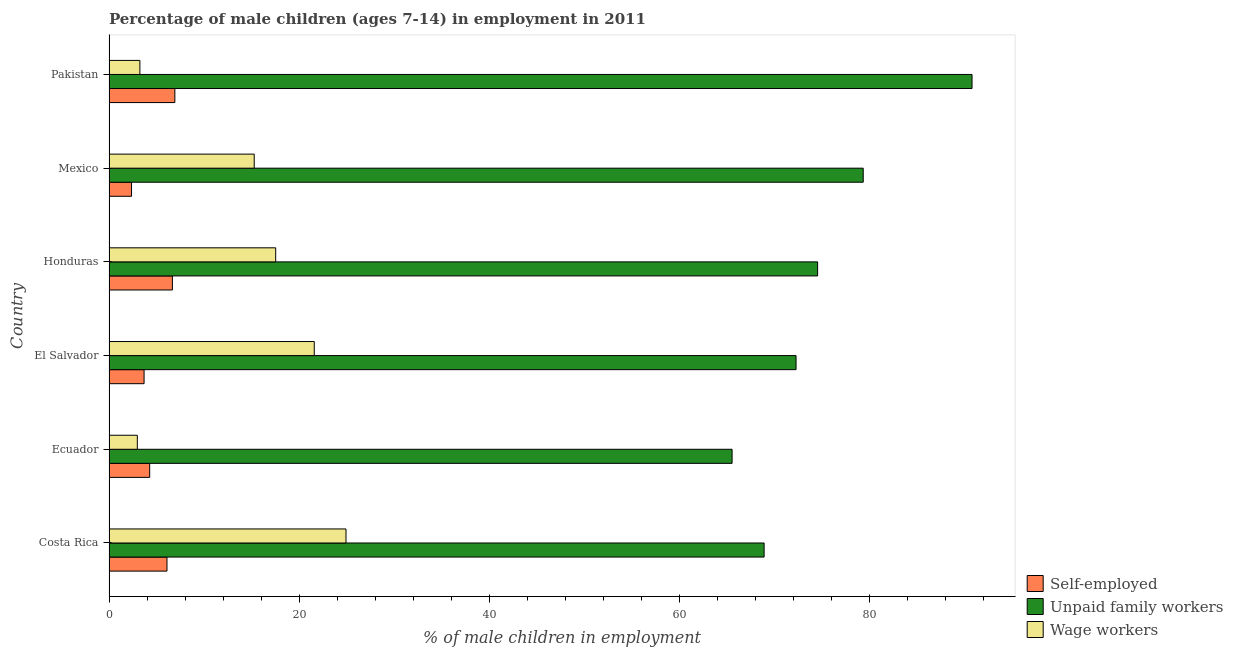How many different coloured bars are there?
Ensure brevity in your answer.  3. How many groups of bars are there?
Offer a terse response. 6. How many bars are there on the 5th tick from the bottom?
Your answer should be compact. 3. What is the percentage of children employed as wage workers in Ecuador?
Provide a succinct answer. 2.98. Across all countries, what is the maximum percentage of self employed children?
Give a very brief answer. 6.93. Across all countries, what is the minimum percentage of children employed as wage workers?
Give a very brief answer. 2.98. In which country was the percentage of children employed as wage workers maximum?
Keep it short and to the point. Costa Rica. What is the total percentage of self employed children in the graph?
Provide a short and direct response. 30.04. What is the difference between the percentage of children employed as wage workers in Mexico and that in Pakistan?
Provide a succinct answer. 12.03. What is the difference between the percentage of children employed as unpaid family workers in Costa Rica and the percentage of children employed as wage workers in Pakistan?
Offer a very short reply. 65.69. What is the average percentage of children employed as unpaid family workers per country?
Offer a terse response. 75.26. What is the difference between the percentage of children employed as wage workers and percentage of self employed children in Costa Rica?
Make the answer very short. 18.84. In how many countries, is the percentage of children employed as unpaid family workers greater than 80 %?
Ensure brevity in your answer.  1. What is the ratio of the percentage of children employed as wage workers in Costa Rica to that in El Salvador?
Give a very brief answer. 1.16. What is the difference between the highest and the second highest percentage of children employed as wage workers?
Provide a short and direct response. 3.34. What is the difference between the highest and the lowest percentage of self employed children?
Offer a very short reply. 4.56. Is the sum of the percentage of self employed children in Costa Rica and Pakistan greater than the maximum percentage of children employed as wage workers across all countries?
Ensure brevity in your answer.  No. What does the 1st bar from the top in El Salvador represents?
Keep it short and to the point. Wage workers. What does the 1st bar from the bottom in Pakistan represents?
Your answer should be compact. Self-employed. Are all the bars in the graph horizontal?
Your answer should be compact. Yes. How many countries are there in the graph?
Offer a terse response. 6. Are the values on the major ticks of X-axis written in scientific E-notation?
Your answer should be compact. No. Does the graph contain any zero values?
Your answer should be compact. No. Where does the legend appear in the graph?
Give a very brief answer. Bottom right. How many legend labels are there?
Offer a terse response. 3. What is the title of the graph?
Provide a short and direct response. Percentage of male children (ages 7-14) in employment in 2011. Does "Social Insurance" appear as one of the legend labels in the graph?
Offer a very short reply. No. What is the label or title of the X-axis?
Your answer should be compact. % of male children in employment. What is the % of male children in employment in Self-employed in Costa Rica?
Offer a terse response. 6.1. What is the % of male children in employment in Unpaid family workers in Costa Rica?
Keep it short and to the point. 68.94. What is the % of male children in employment of Wage workers in Costa Rica?
Provide a short and direct response. 24.94. What is the % of male children in employment in Self-employed in Ecuador?
Ensure brevity in your answer.  4.28. What is the % of male children in employment in Unpaid family workers in Ecuador?
Offer a terse response. 65.57. What is the % of male children in employment in Wage workers in Ecuador?
Provide a short and direct response. 2.98. What is the % of male children in employment of Self-employed in El Salvador?
Provide a succinct answer. 3.69. What is the % of male children in employment of Unpaid family workers in El Salvador?
Ensure brevity in your answer.  72.3. What is the % of male children in employment of Wage workers in El Salvador?
Provide a succinct answer. 21.6. What is the % of male children in employment in Self-employed in Honduras?
Ensure brevity in your answer.  6.67. What is the % of male children in employment of Unpaid family workers in Honduras?
Provide a short and direct response. 74.57. What is the % of male children in employment of Wage workers in Honduras?
Make the answer very short. 17.54. What is the % of male children in employment of Self-employed in Mexico?
Offer a terse response. 2.37. What is the % of male children in employment of Unpaid family workers in Mexico?
Give a very brief answer. 79.37. What is the % of male children in employment in Wage workers in Mexico?
Ensure brevity in your answer.  15.28. What is the % of male children in employment in Self-employed in Pakistan?
Offer a terse response. 6.93. What is the % of male children in employment of Unpaid family workers in Pakistan?
Your answer should be very brief. 90.82. Across all countries, what is the maximum % of male children in employment in Self-employed?
Your answer should be very brief. 6.93. Across all countries, what is the maximum % of male children in employment in Unpaid family workers?
Give a very brief answer. 90.82. Across all countries, what is the maximum % of male children in employment of Wage workers?
Keep it short and to the point. 24.94. Across all countries, what is the minimum % of male children in employment of Self-employed?
Provide a short and direct response. 2.37. Across all countries, what is the minimum % of male children in employment of Unpaid family workers?
Ensure brevity in your answer.  65.57. Across all countries, what is the minimum % of male children in employment of Wage workers?
Ensure brevity in your answer.  2.98. What is the total % of male children in employment of Self-employed in the graph?
Offer a very short reply. 30.04. What is the total % of male children in employment in Unpaid family workers in the graph?
Ensure brevity in your answer.  451.57. What is the total % of male children in employment in Wage workers in the graph?
Offer a very short reply. 85.59. What is the difference between the % of male children in employment in Self-employed in Costa Rica and that in Ecuador?
Your answer should be compact. 1.82. What is the difference between the % of male children in employment in Unpaid family workers in Costa Rica and that in Ecuador?
Give a very brief answer. 3.37. What is the difference between the % of male children in employment of Wage workers in Costa Rica and that in Ecuador?
Ensure brevity in your answer.  21.96. What is the difference between the % of male children in employment in Self-employed in Costa Rica and that in El Salvador?
Ensure brevity in your answer.  2.41. What is the difference between the % of male children in employment of Unpaid family workers in Costa Rica and that in El Salvador?
Your answer should be compact. -3.36. What is the difference between the % of male children in employment of Wage workers in Costa Rica and that in El Salvador?
Offer a terse response. 3.34. What is the difference between the % of male children in employment of Self-employed in Costa Rica and that in Honduras?
Give a very brief answer. -0.57. What is the difference between the % of male children in employment of Unpaid family workers in Costa Rica and that in Honduras?
Offer a terse response. -5.63. What is the difference between the % of male children in employment of Self-employed in Costa Rica and that in Mexico?
Keep it short and to the point. 3.73. What is the difference between the % of male children in employment of Unpaid family workers in Costa Rica and that in Mexico?
Give a very brief answer. -10.43. What is the difference between the % of male children in employment of Wage workers in Costa Rica and that in Mexico?
Your response must be concise. 9.66. What is the difference between the % of male children in employment in Self-employed in Costa Rica and that in Pakistan?
Your answer should be compact. -0.83. What is the difference between the % of male children in employment of Unpaid family workers in Costa Rica and that in Pakistan?
Your response must be concise. -21.88. What is the difference between the % of male children in employment of Wage workers in Costa Rica and that in Pakistan?
Offer a terse response. 21.69. What is the difference between the % of male children in employment in Self-employed in Ecuador and that in El Salvador?
Your response must be concise. 0.59. What is the difference between the % of male children in employment of Unpaid family workers in Ecuador and that in El Salvador?
Provide a short and direct response. -6.73. What is the difference between the % of male children in employment of Wage workers in Ecuador and that in El Salvador?
Keep it short and to the point. -18.62. What is the difference between the % of male children in employment of Self-employed in Ecuador and that in Honduras?
Your answer should be very brief. -2.39. What is the difference between the % of male children in employment in Wage workers in Ecuador and that in Honduras?
Your answer should be very brief. -14.56. What is the difference between the % of male children in employment of Self-employed in Ecuador and that in Mexico?
Provide a short and direct response. 1.91. What is the difference between the % of male children in employment in Unpaid family workers in Ecuador and that in Mexico?
Your response must be concise. -13.8. What is the difference between the % of male children in employment of Self-employed in Ecuador and that in Pakistan?
Your answer should be very brief. -2.65. What is the difference between the % of male children in employment of Unpaid family workers in Ecuador and that in Pakistan?
Offer a very short reply. -25.25. What is the difference between the % of male children in employment in Wage workers in Ecuador and that in Pakistan?
Make the answer very short. -0.27. What is the difference between the % of male children in employment in Self-employed in El Salvador and that in Honduras?
Your answer should be very brief. -2.98. What is the difference between the % of male children in employment of Unpaid family workers in El Salvador and that in Honduras?
Your answer should be compact. -2.27. What is the difference between the % of male children in employment in Wage workers in El Salvador and that in Honduras?
Provide a short and direct response. 4.06. What is the difference between the % of male children in employment of Self-employed in El Salvador and that in Mexico?
Your answer should be compact. 1.32. What is the difference between the % of male children in employment of Unpaid family workers in El Salvador and that in Mexico?
Give a very brief answer. -7.07. What is the difference between the % of male children in employment of Wage workers in El Salvador and that in Mexico?
Provide a short and direct response. 6.32. What is the difference between the % of male children in employment of Self-employed in El Salvador and that in Pakistan?
Make the answer very short. -3.24. What is the difference between the % of male children in employment of Unpaid family workers in El Salvador and that in Pakistan?
Your answer should be compact. -18.52. What is the difference between the % of male children in employment of Wage workers in El Salvador and that in Pakistan?
Ensure brevity in your answer.  18.35. What is the difference between the % of male children in employment in Unpaid family workers in Honduras and that in Mexico?
Give a very brief answer. -4.8. What is the difference between the % of male children in employment of Wage workers in Honduras and that in Mexico?
Offer a very short reply. 2.26. What is the difference between the % of male children in employment of Self-employed in Honduras and that in Pakistan?
Your answer should be very brief. -0.26. What is the difference between the % of male children in employment in Unpaid family workers in Honduras and that in Pakistan?
Offer a very short reply. -16.25. What is the difference between the % of male children in employment of Wage workers in Honduras and that in Pakistan?
Your answer should be compact. 14.29. What is the difference between the % of male children in employment in Self-employed in Mexico and that in Pakistan?
Offer a terse response. -4.56. What is the difference between the % of male children in employment in Unpaid family workers in Mexico and that in Pakistan?
Your response must be concise. -11.45. What is the difference between the % of male children in employment of Wage workers in Mexico and that in Pakistan?
Offer a terse response. 12.03. What is the difference between the % of male children in employment in Self-employed in Costa Rica and the % of male children in employment in Unpaid family workers in Ecuador?
Keep it short and to the point. -59.47. What is the difference between the % of male children in employment in Self-employed in Costa Rica and the % of male children in employment in Wage workers in Ecuador?
Provide a short and direct response. 3.12. What is the difference between the % of male children in employment of Unpaid family workers in Costa Rica and the % of male children in employment of Wage workers in Ecuador?
Your response must be concise. 65.96. What is the difference between the % of male children in employment in Self-employed in Costa Rica and the % of male children in employment in Unpaid family workers in El Salvador?
Provide a short and direct response. -66.2. What is the difference between the % of male children in employment in Self-employed in Costa Rica and the % of male children in employment in Wage workers in El Salvador?
Provide a short and direct response. -15.5. What is the difference between the % of male children in employment of Unpaid family workers in Costa Rica and the % of male children in employment of Wage workers in El Salvador?
Give a very brief answer. 47.34. What is the difference between the % of male children in employment of Self-employed in Costa Rica and the % of male children in employment of Unpaid family workers in Honduras?
Your response must be concise. -68.47. What is the difference between the % of male children in employment in Self-employed in Costa Rica and the % of male children in employment in Wage workers in Honduras?
Give a very brief answer. -11.44. What is the difference between the % of male children in employment in Unpaid family workers in Costa Rica and the % of male children in employment in Wage workers in Honduras?
Give a very brief answer. 51.4. What is the difference between the % of male children in employment in Self-employed in Costa Rica and the % of male children in employment in Unpaid family workers in Mexico?
Make the answer very short. -73.27. What is the difference between the % of male children in employment in Self-employed in Costa Rica and the % of male children in employment in Wage workers in Mexico?
Your response must be concise. -9.18. What is the difference between the % of male children in employment of Unpaid family workers in Costa Rica and the % of male children in employment of Wage workers in Mexico?
Ensure brevity in your answer.  53.66. What is the difference between the % of male children in employment in Self-employed in Costa Rica and the % of male children in employment in Unpaid family workers in Pakistan?
Offer a very short reply. -84.72. What is the difference between the % of male children in employment of Self-employed in Costa Rica and the % of male children in employment of Wage workers in Pakistan?
Make the answer very short. 2.85. What is the difference between the % of male children in employment of Unpaid family workers in Costa Rica and the % of male children in employment of Wage workers in Pakistan?
Provide a short and direct response. 65.69. What is the difference between the % of male children in employment of Self-employed in Ecuador and the % of male children in employment of Unpaid family workers in El Salvador?
Make the answer very short. -68.02. What is the difference between the % of male children in employment in Self-employed in Ecuador and the % of male children in employment in Wage workers in El Salvador?
Offer a very short reply. -17.32. What is the difference between the % of male children in employment of Unpaid family workers in Ecuador and the % of male children in employment of Wage workers in El Salvador?
Offer a terse response. 43.97. What is the difference between the % of male children in employment of Self-employed in Ecuador and the % of male children in employment of Unpaid family workers in Honduras?
Offer a terse response. -70.29. What is the difference between the % of male children in employment in Self-employed in Ecuador and the % of male children in employment in Wage workers in Honduras?
Make the answer very short. -13.26. What is the difference between the % of male children in employment in Unpaid family workers in Ecuador and the % of male children in employment in Wage workers in Honduras?
Give a very brief answer. 48.03. What is the difference between the % of male children in employment of Self-employed in Ecuador and the % of male children in employment of Unpaid family workers in Mexico?
Provide a short and direct response. -75.09. What is the difference between the % of male children in employment of Self-employed in Ecuador and the % of male children in employment of Wage workers in Mexico?
Provide a succinct answer. -11. What is the difference between the % of male children in employment in Unpaid family workers in Ecuador and the % of male children in employment in Wage workers in Mexico?
Keep it short and to the point. 50.29. What is the difference between the % of male children in employment in Self-employed in Ecuador and the % of male children in employment in Unpaid family workers in Pakistan?
Make the answer very short. -86.54. What is the difference between the % of male children in employment of Self-employed in Ecuador and the % of male children in employment of Wage workers in Pakistan?
Your answer should be very brief. 1.03. What is the difference between the % of male children in employment in Unpaid family workers in Ecuador and the % of male children in employment in Wage workers in Pakistan?
Provide a short and direct response. 62.32. What is the difference between the % of male children in employment in Self-employed in El Salvador and the % of male children in employment in Unpaid family workers in Honduras?
Your answer should be compact. -70.88. What is the difference between the % of male children in employment of Self-employed in El Salvador and the % of male children in employment of Wage workers in Honduras?
Keep it short and to the point. -13.85. What is the difference between the % of male children in employment of Unpaid family workers in El Salvador and the % of male children in employment of Wage workers in Honduras?
Provide a succinct answer. 54.76. What is the difference between the % of male children in employment of Self-employed in El Salvador and the % of male children in employment of Unpaid family workers in Mexico?
Your response must be concise. -75.68. What is the difference between the % of male children in employment in Self-employed in El Salvador and the % of male children in employment in Wage workers in Mexico?
Your answer should be compact. -11.59. What is the difference between the % of male children in employment of Unpaid family workers in El Salvador and the % of male children in employment of Wage workers in Mexico?
Make the answer very short. 57.02. What is the difference between the % of male children in employment in Self-employed in El Salvador and the % of male children in employment in Unpaid family workers in Pakistan?
Keep it short and to the point. -87.13. What is the difference between the % of male children in employment of Self-employed in El Salvador and the % of male children in employment of Wage workers in Pakistan?
Provide a short and direct response. 0.44. What is the difference between the % of male children in employment of Unpaid family workers in El Salvador and the % of male children in employment of Wage workers in Pakistan?
Provide a succinct answer. 69.05. What is the difference between the % of male children in employment of Self-employed in Honduras and the % of male children in employment of Unpaid family workers in Mexico?
Your answer should be very brief. -72.7. What is the difference between the % of male children in employment in Self-employed in Honduras and the % of male children in employment in Wage workers in Mexico?
Offer a very short reply. -8.61. What is the difference between the % of male children in employment of Unpaid family workers in Honduras and the % of male children in employment of Wage workers in Mexico?
Your answer should be compact. 59.29. What is the difference between the % of male children in employment in Self-employed in Honduras and the % of male children in employment in Unpaid family workers in Pakistan?
Your answer should be compact. -84.15. What is the difference between the % of male children in employment of Self-employed in Honduras and the % of male children in employment of Wage workers in Pakistan?
Offer a terse response. 3.42. What is the difference between the % of male children in employment in Unpaid family workers in Honduras and the % of male children in employment in Wage workers in Pakistan?
Offer a terse response. 71.32. What is the difference between the % of male children in employment in Self-employed in Mexico and the % of male children in employment in Unpaid family workers in Pakistan?
Keep it short and to the point. -88.45. What is the difference between the % of male children in employment of Self-employed in Mexico and the % of male children in employment of Wage workers in Pakistan?
Your answer should be compact. -0.88. What is the difference between the % of male children in employment of Unpaid family workers in Mexico and the % of male children in employment of Wage workers in Pakistan?
Your answer should be very brief. 76.12. What is the average % of male children in employment in Self-employed per country?
Your answer should be very brief. 5.01. What is the average % of male children in employment in Unpaid family workers per country?
Make the answer very short. 75.26. What is the average % of male children in employment in Wage workers per country?
Keep it short and to the point. 14.27. What is the difference between the % of male children in employment of Self-employed and % of male children in employment of Unpaid family workers in Costa Rica?
Give a very brief answer. -62.84. What is the difference between the % of male children in employment of Self-employed and % of male children in employment of Wage workers in Costa Rica?
Give a very brief answer. -18.84. What is the difference between the % of male children in employment in Unpaid family workers and % of male children in employment in Wage workers in Costa Rica?
Your answer should be very brief. 44. What is the difference between the % of male children in employment in Self-employed and % of male children in employment in Unpaid family workers in Ecuador?
Give a very brief answer. -61.29. What is the difference between the % of male children in employment of Unpaid family workers and % of male children in employment of Wage workers in Ecuador?
Ensure brevity in your answer.  62.59. What is the difference between the % of male children in employment of Self-employed and % of male children in employment of Unpaid family workers in El Salvador?
Offer a terse response. -68.61. What is the difference between the % of male children in employment of Self-employed and % of male children in employment of Wage workers in El Salvador?
Offer a terse response. -17.91. What is the difference between the % of male children in employment of Unpaid family workers and % of male children in employment of Wage workers in El Salvador?
Give a very brief answer. 50.7. What is the difference between the % of male children in employment in Self-employed and % of male children in employment in Unpaid family workers in Honduras?
Ensure brevity in your answer.  -67.9. What is the difference between the % of male children in employment of Self-employed and % of male children in employment of Wage workers in Honduras?
Make the answer very short. -10.87. What is the difference between the % of male children in employment in Unpaid family workers and % of male children in employment in Wage workers in Honduras?
Your answer should be compact. 57.03. What is the difference between the % of male children in employment in Self-employed and % of male children in employment in Unpaid family workers in Mexico?
Your response must be concise. -77. What is the difference between the % of male children in employment in Self-employed and % of male children in employment in Wage workers in Mexico?
Ensure brevity in your answer.  -12.91. What is the difference between the % of male children in employment of Unpaid family workers and % of male children in employment of Wage workers in Mexico?
Offer a very short reply. 64.09. What is the difference between the % of male children in employment in Self-employed and % of male children in employment in Unpaid family workers in Pakistan?
Provide a short and direct response. -83.89. What is the difference between the % of male children in employment in Self-employed and % of male children in employment in Wage workers in Pakistan?
Your answer should be compact. 3.68. What is the difference between the % of male children in employment in Unpaid family workers and % of male children in employment in Wage workers in Pakistan?
Your answer should be compact. 87.57. What is the ratio of the % of male children in employment in Self-employed in Costa Rica to that in Ecuador?
Ensure brevity in your answer.  1.43. What is the ratio of the % of male children in employment of Unpaid family workers in Costa Rica to that in Ecuador?
Provide a succinct answer. 1.05. What is the ratio of the % of male children in employment in Wage workers in Costa Rica to that in Ecuador?
Your answer should be very brief. 8.37. What is the ratio of the % of male children in employment of Self-employed in Costa Rica to that in El Salvador?
Provide a short and direct response. 1.65. What is the ratio of the % of male children in employment in Unpaid family workers in Costa Rica to that in El Salvador?
Your response must be concise. 0.95. What is the ratio of the % of male children in employment in Wage workers in Costa Rica to that in El Salvador?
Your answer should be very brief. 1.15. What is the ratio of the % of male children in employment of Self-employed in Costa Rica to that in Honduras?
Provide a succinct answer. 0.91. What is the ratio of the % of male children in employment of Unpaid family workers in Costa Rica to that in Honduras?
Give a very brief answer. 0.92. What is the ratio of the % of male children in employment of Wage workers in Costa Rica to that in Honduras?
Provide a short and direct response. 1.42. What is the ratio of the % of male children in employment of Self-employed in Costa Rica to that in Mexico?
Give a very brief answer. 2.57. What is the ratio of the % of male children in employment in Unpaid family workers in Costa Rica to that in Mexico?
Keep it short and to the point. 0.87. What is the ratio of the % of male children in employment of Wage workers in Costa Rica to that in Mexico?
Make the answer very short. 1.63. What is the ratio of the % of male children in employment in Self-employed in Costa Rica to that in Pakistan?
Offer a terse response. 0.88. What is the ratio of the % of male children in employment of Unpaid family workers in Costa Rica to that in Pakistan?
Offer a terse response. 0.76. What is the ratio of the % of male children in employment in Wage workers in Costa Rica to that in Pakistan?
Provide a short and direct response. 7.67. What is the ratio of the % of male children in employment of Self-employed in Ecuador to that in El Salvador?
Give a very brief answer. 1.16. What is the ratio of the % of male children in employment in Unpaid family workers in Ecuador to that in El Salvador?
Provide a short and direct response. 0.91. What is the ratio of the % of male children in employment in Wage workers in Ecuador to that in El Salvador?
Your answer should be compact. 0.14. What is the ratio of the % of male children in employment of Self-employed in Ecuador to that in Honduras?
Make the answer very short. 0.64. What is the ratio of the % of male children in employment of Unpaid family workers in Ecuador to that in Honduras?
Your response must be concise. 0.88. What is the ratio of the % of male children in employment in Wage workers in Ecuador to that in Honduras?
Offer a very short reply. 0.17. What is the ratio of the % of male children in employment of Self-employed in Ecuador to that in Mexico?
Your response must be concise. 1.81. What is the ratio of the % of male children in employment of Unpaid family workers in Ecuador to that in Mexico?
Your answer should be very brief. 0.83. What is the ratio of the % of male children in employment in Wage workers in Ecuador to that in Mexico?
Your response must be concise. 0.2. What is the ratio of the % of male children in employment in Self-employed in Ecuador to that in Pakistan?
Make the answer very short. 0.62. What is the ratio of the % of male children in employment in Unpaid family workers in Ecuador to that in Pakistan?
Your answer should be compact. 0.72. What is the ratio of the % of male children in employment in Wage workers in Ecuador to that in Pakistan?
Give a very brief answer. 0.92. What is the ratio of the % of male children in employment of Self-employed in El Salvador to that in Honduras?
Provide a succinct answer. 0.55. What is the ratio of the % of male children in employment in Unpaid family workers in El Salvador to that in Honduras?
Make the answer very short. 0.97. What is the ratio of the % of male children in employment of Wage workers in El Salvador to that in Honduras?
Your response must be concise. 1.23. What is the ratio of the % of male children in employment of Self-employed in El Salvador to that in Mexico?
Offer a very short reply. 1.56. What is the ratio of the % of male children in employment in Unpaid family workers in El Salvador to that in Mexico?
Your response must be concise. 0.91. What is the ratio of the % of male children in employment in Wage workers in El Salvador to that in Mexico?
Give a very brief answer. 1.41. What is the ratio of the % of male children in employment of Self-employed in El Salvador to that in Pakistan?
Provide a short and direct response. 0.53. What is the ratio of the % of male children in employment of Unpaid family workers in El Salvador to that in Pakistan?
Offer a terse response. 0.8. What is the ratio of the % of male children in employment of Wage workers in El Salvador to that in Pakistan?
Keep it short and to the point. 6.65. What is the ratio of the % of male children in employment in Self-employed in Honduras to that in Mexico?
Your response must be concise. 2.81. What is the ratio of the % of male children in employment of Unpaid family workers in Honduras to that in Mexico?
Make the answer very short. 0.94. What is the ratio of the % of male children in employment of Wage workers in Honduras to that in Mexico?
Your response must be concise. 1.15. What is the ratio of the % of male children in employment in Self-employed in Honduras to that in Pakistan?
Make the answer very short. 0.96. What is the ratio of the % of male children in employment of Unpaid family workers in Honduras to that in Pakistan?
Offer a very short reply. 0.82. What is the ratio of the % of male children in employment of Wage workers in Honduras to that in Pakistan?
Your response must be concise. 5.4. What is the ratio of the % of male children in employment of Self-employed in Mexico to that in Pakistan?
Offer a very short reply. 0.34. What is the ratio of the % of male children in employment in Unpaid family workers in Mexico to that in Pakistan?
Make the answer very short. 0.87. What is the ratio of the % of male children in employment in Wage workers in Mexico to that in Pakistan?
Give a very brief answer. 4.7. What is the difference between the highest and the second highest % of male children in employment in Self-employed?
Offer a very short reply. 0.26. What is the difference between the highest and the second highest % of male children in employment of Unpaid family workers?
Make the answer very short. 11.45. What is the difference between the highest and the second highest % of male children in employment of Wage workers?
Your answer should be very brief. 3.34. What is the difference between the highest and the lowest % of male children in employment in Self-employed?
Ensure brevity in your answer.  4.56. What is the difference between the highest and the lowest % of male children in employment of Unpaid family workers?
Provide a succinct answer. 25.25. What is the difference between the highest and the lowest % of male children in employment of Wage workers?
Provide a short and direct response. 21.96. 